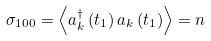<formula> <loc_0><loc_0><loc_500><loc_500>\sigma _ { 1 0 0 } = \left \langle a _ { k } ^ { \dagger } \left ( t _ { 1 } \right ) a _ { k } \left ( t _ { 1 } \right ) \right \rangle = n</formula> 